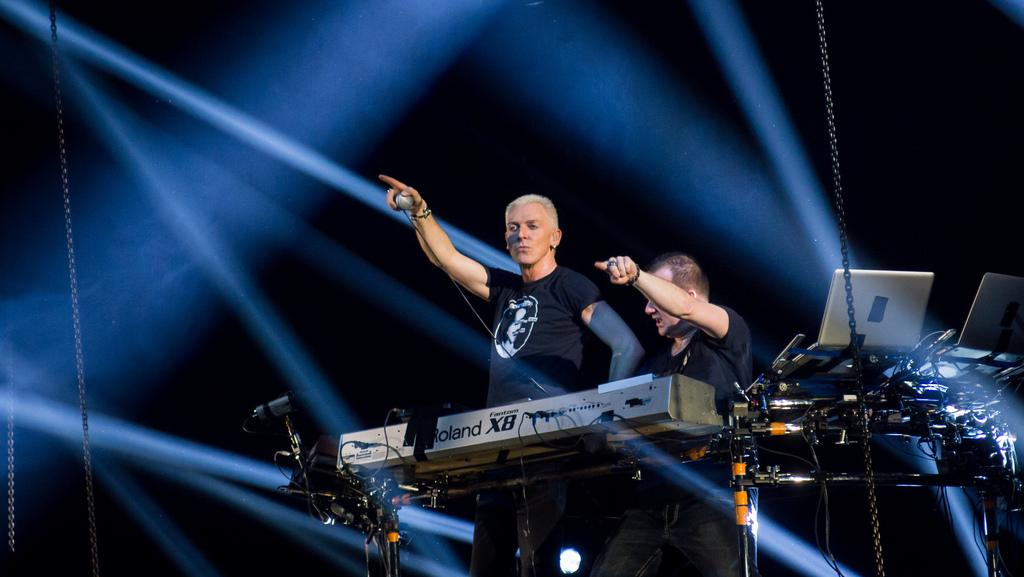What is the man in the image doing with his finger? The man in the image is standing and pointing his finger. What is the man wearing in the image? The man is wearing a black t-shirt. Can you describe the other person in the image? There is another man beside him in the image, and he is also wearing a black t-shirt. What type of potato is the man holding in the image? There is no potato present in the image; the man is pointing his finger. Who is the owner of the black t-shirts in the image? The facts provided do not indicate who owns the black t-shirts, as both men are wearing them. 